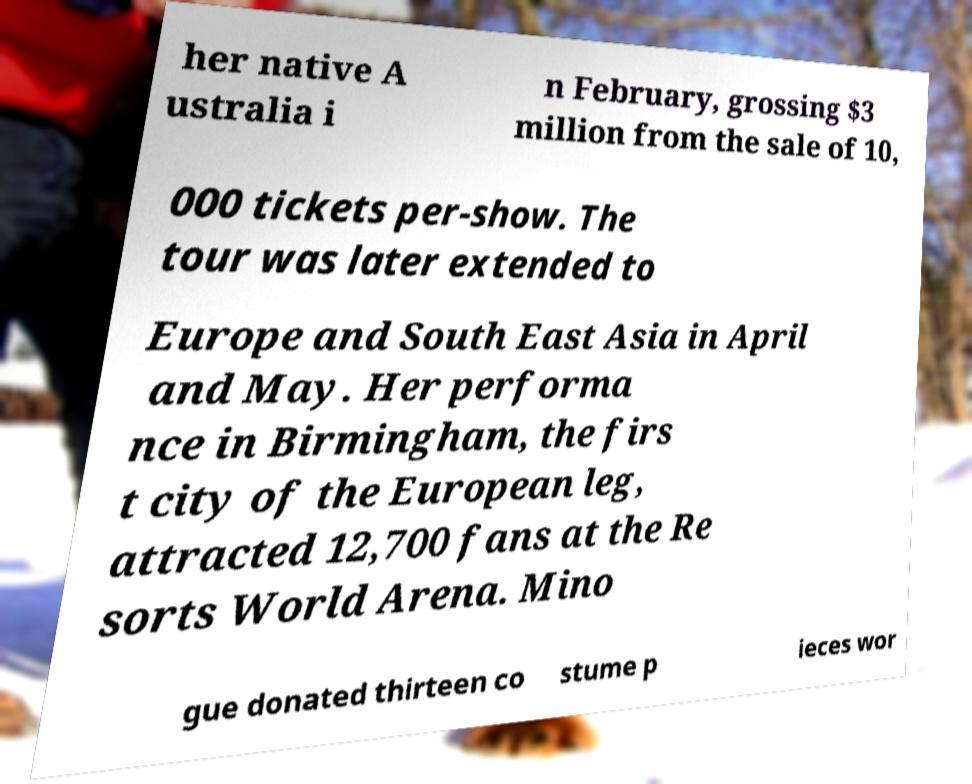For documentation purposes, I need the text within this image transcribed. Could you provide that? her native A ustralia i n February, grossing $3 million from the sale of 10, 000 tickets per-show. The tour was later extended to Europe and South East Asia in April and May. Her performa nce in Birmingham, the firs t city of the European leg, attracted 12,700 fans at the Re sorts World Arena. Mino gue donated thirteen co stume p ieces wor 